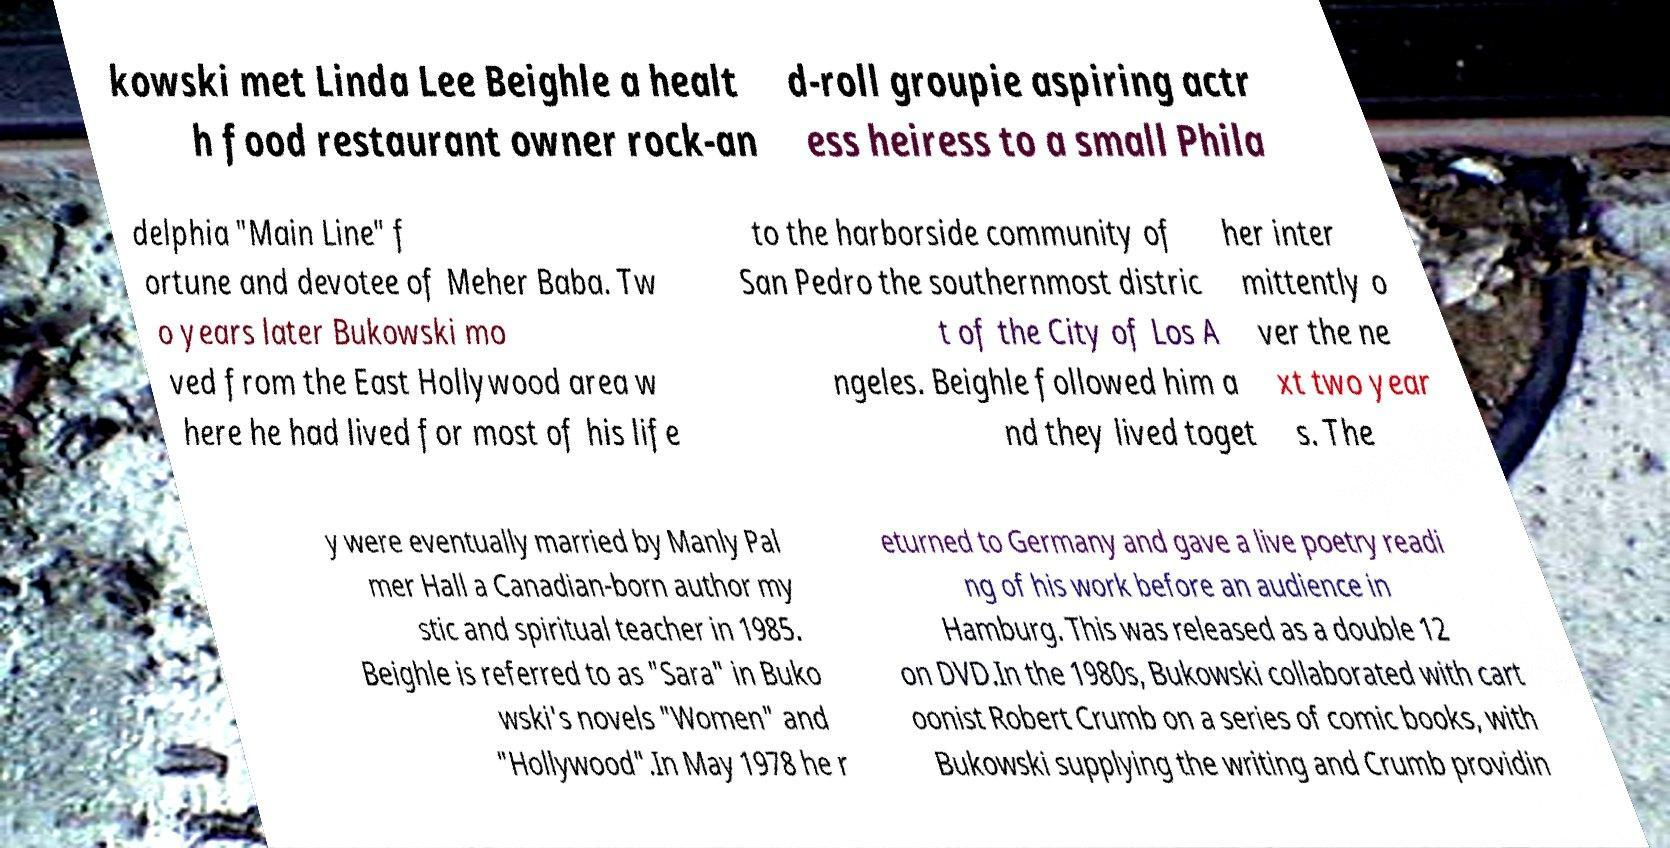For documentation purposes, I need the text within this image transcribed. Could you provide that? kowski met Linda Lee Beighle a healt h food restaurant owner rock-an d-roll groupie aspiring actr ess heiress to a small Phila delphia "Main Line" f ortune and devotee of Meher Baba. Tw o years later Bukowski mo ved from the East Hollywood area w here he had lived for most of his life to the harborside community of San Pedro the southernmost distric t of the City of Los A ngeles. Beighle followed him a nd they lived toget her inter mittently o ver the ne xt two year s. The y were eventually married by Manly Pal mer Hall a Canadian-born author my stic and spiritual teacher in 1985. Beighle is referred to as "Sara" in Buko wski's novels "Women" and "Hollywood".In May 1978 he r eturned to Germany and gave a live poetry readi ng of his work before an audience in Hamburg. This was released as a double 12 on DVD.In the 1980s, Bukowski collaborated with cart oonist Robert Crumb on a series of comic books, with Bukowski supplying the writing and Crumb providin 